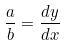Convert formula to latex. <formula><loc_0><loc_0><loc_500><loc_500>\frac { a } { b } = \frac { d y } { d x }</formula> 